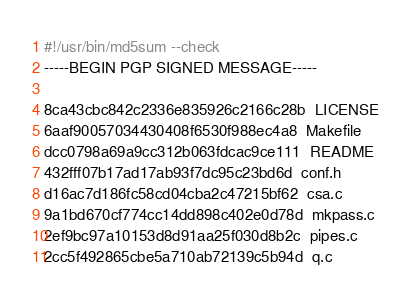<code> <loc_0><loc_0><loc_500><loc_500><_Bash_>#!/usr/bin/md5sum --check
-----BEGIN PGP SIGNED MESSAGE-----

8ca43cbc842c2336e835926c2166c28b  LICENSE
6aaf90057034430408f6530f988ec4a8  Makefile
dcc0798a69a9cc312b063fdcac9ce111  README
432fff07b17ad17ab93f7dc95c23bd6d  conf.h
d16ac7d186fc58cd04cba2c47215bf62  csa.c
9a1bd670cf774cc14dd898c402e0d78d  mkpass.c
2ef9bc97a10153d8d91aa25f030d8b2c  pipes.c
2cc5f492865cbe5a710ab72139c5b94d  q.c</code> 